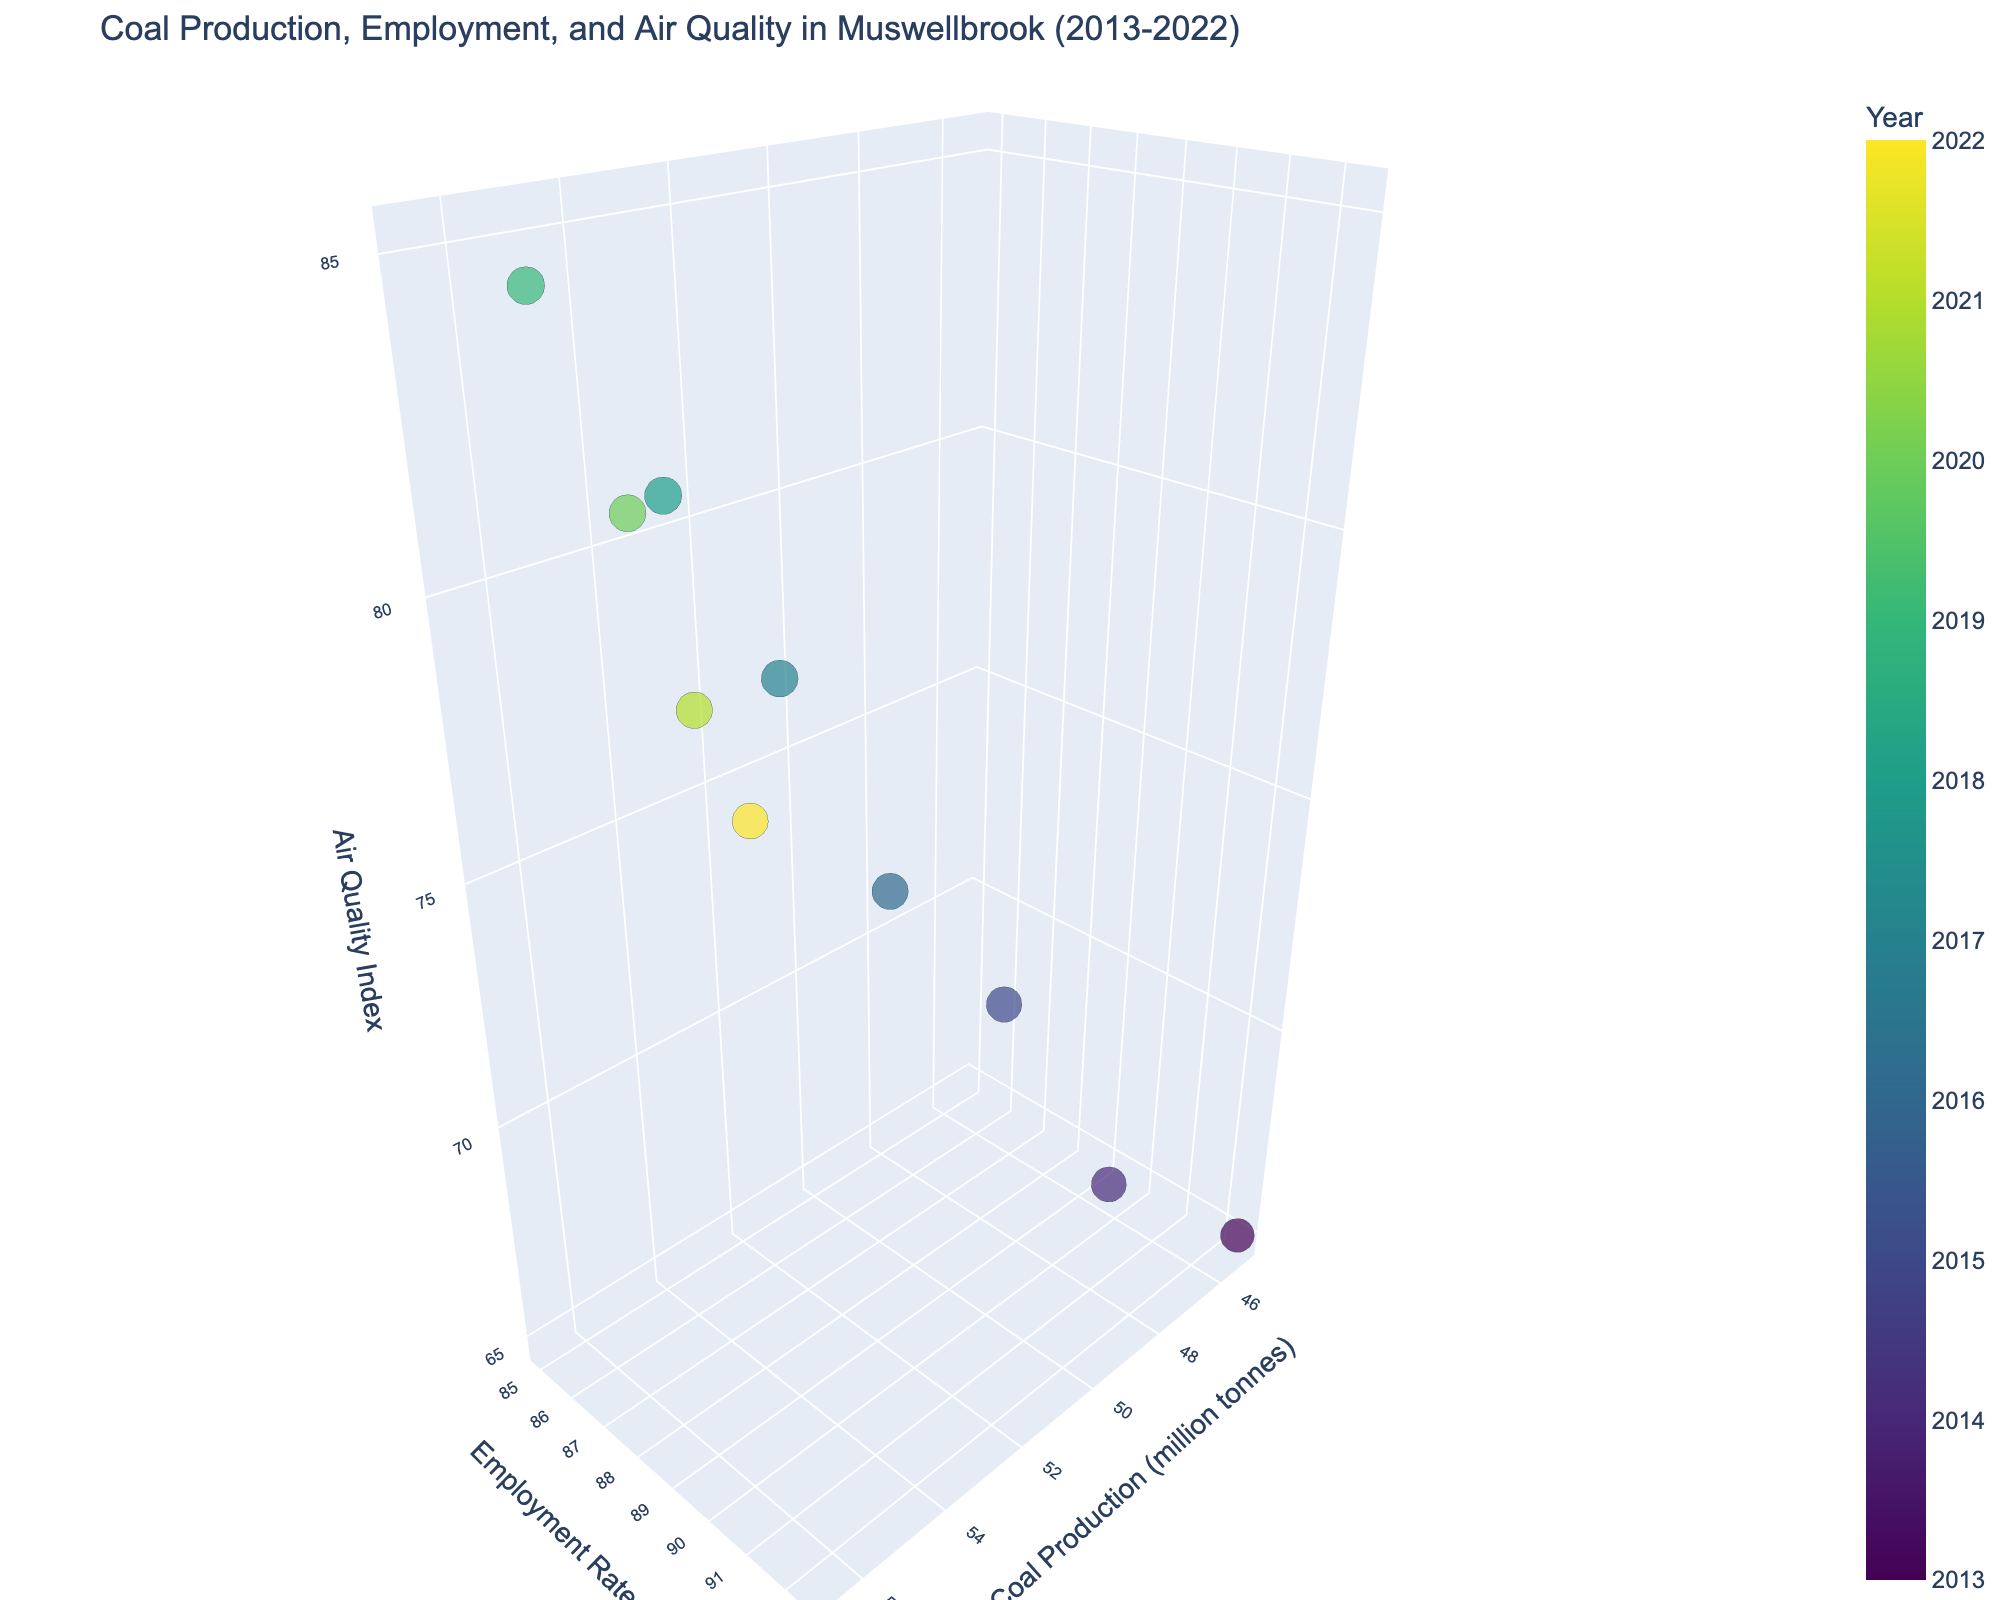what is the range of air quality indices in the figure? The air quality index values range from 65 in 2013 (Mt Arthur Coal Mine) to 85 in 2019 (Liddell Coal Operations).
Answer: 65 to 85 What is the trend of coal production volume over the years? The coal production volume generally increased from 45.2 million tonnes in 2013 to a peak of 56.7 million tonnes in 2019, and then it decreased to 51.2 million tonnes in 2022.
Answer: Increasing until 2019, then decreasing Which year had the highest employment rate, and what was the coal production volume in that year? The highest employment rate was 92.5% in 2013, and the coal production volume that year was 45.2 million tonnes.
Answer: 2013, 45.2 million tonnes Is there a relationship between coal production volume and air quality index over the years? The chart shows a trend where an increase in coal production volume is associated with a higher air quality index (worsening air quality), up until around 2019, after which both production and air quality index decreased.
Answer: Increasing coal production correlates with worsening air quality Between which years did coal production volume see the largest increase, and by how much? The largest increase in coal production volume occurred between 2017 and 2018, with an increment from 53.8 to 55.2 million tonnes, a difference of 1.4 million tonnes.
Answer: 2017-2018, 1.4 million tonnes How does the size of the bubble correlate with the coal production volume in the 3D bubble chart? The size of the bubble represents the coal production volume, with larger bubbles indicating higher production. For example, the largest bubbles are seen around 2018 and 2019 when the production volumes are highest.
Answer: Larger bubbles indicate higher coal production What is the general trend in employment rates over the past decade? Employment rates show a general declining trend from 92.5% in 2013 to 84.9% in 2022.
Answer: Declining Which mine had the highest air quality index, and in what year? Liddell Coal Operations had the highest air quality index of 85, in the year 2019.
Answer: Liddell Coal Operations, 2019 In what year did the coal production volume start to decline, and how is it reflected in the 3D bubble chart? Coal production volume started to decline after 2019, as reflected by the smaller bubbles and lower values on the x-axis from 2020 to 2022.
Answer: After 2019 How many data points (years) are displayed in the 3D bubble chart? The chart displays 10 data points, representing the years from 2013 to 2022.
Answer: 10 